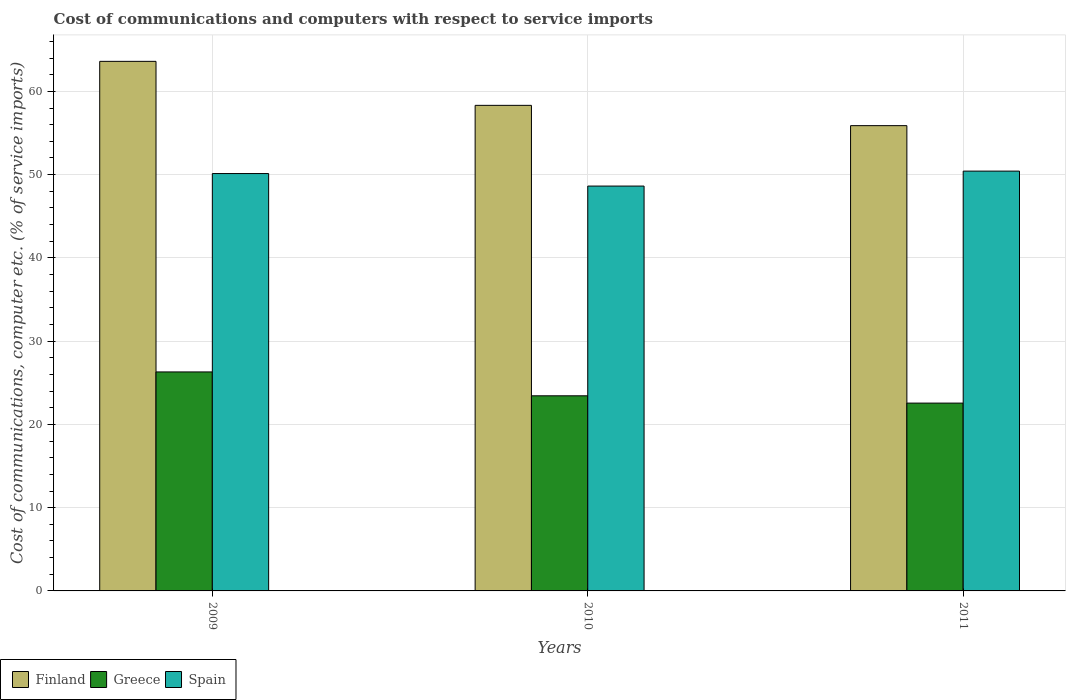How many different coloured bars are there?
Your answer should be very brief. 3. How many groups of bars are there?
Give a very brief answer. 3. Are the number of bars per tick equal to the number of legend labels?
Provide a short and direct response. Yes. Are the number of bars on each tick of the X-axis equal?
Keep it short and to the point. Yes. In how many cases, is the number of bars for a given year not equal to the number of legend labels?
Offer a terse response. 0. What is the cost of communications and computers in Spain in 2011?
Provide a succinct answer. 50.42. Across all years, what is the maximum cost of communications and computers in Spain?
Keep it short and to the point. 50.42. Across all years, what is the minimum cost of communications and computers in Greece?
Your answer should be compact. 22.56. In which year was the cost of communications and computers in Finland minimum?
Your answer should be compact. 2011. What is the total cost of communications and computers in Spain in the graph?
Your answer should be compact. 149.18. What is the difference between the cost of communications and computers in Spain in 2010 and that in 2011?
Ensure brevity in your answer.  -1.79. What is the difference between the cost of communications and computers in Finland in 2010 and the cost of communications and computers in Greece in 2009?
Ensure brevity in your answer.  32.02. What is the average cost of communications and computers in Greece per year?
Provide a succinct answer. 24.1. In the year 2011, what is the difference between the cost of communications and computers in Spain and cost of communications and computers in Finland?
Make the answer very short. -5.46. In how many years, is the cost of communications and computers in Spain greater than 58 %?
Give a very brief answer. 0. What is the ratio of the cost of communications and computers in Finland in 2009 to that in 2011?
Ensure brevity in your answer.  1.14. Is the cost of communications and computers in Spain in 2009 less than that in 2010?
Provide a succinct answer. No. What is the difference between the highest and the second highest cost of communications and computers in Spain?
Keep it short and to the point. 0.29. What is the difference between the highest and the lowest cost of communications and computers in Finland?
Ensure brevity in your answer.  7.72. In how many years, is the cost of communications and computers in Spain greater than the average cost of communications and computers in Spain taken over all years?
Your answer should be compact. 2. Is the sum of the cost of communications and computers in Finland in 2009 and 2010 greater than the maximum cost of communications and computers in Greece across all years?
Make the answer very short. Yes. What does the 3rd bar from the left in 2011 represents?
Offer a terse response. Spain. How many bars are there?
Ensure brevity in your answer.  9. What is the difference between two consecutive major ticks on the Y-axis?
Offer a very short reply. 10. Does the graph contain any zero values?
Your answer should be compact. No. Does the graph contain grids?
Your response must be concise. Yes. Where does the legend appear in the graph?
Give a very brief answer. Bottom left. How many legend labels are there?
Ensure brevity in your answer.  3. How are the legend labels stacked?
Ensure brevity in your answer.  Horizontal. What is the title of the graph?
Offer a terse response. Cost of communications and computers with respect to service imports. What is the label or title of the Y-axis?
Offer a very short reply. Cost of communications, computer etc. (% of service imports). What is the Cost of communications, computer etc. (% of service imports) of Finland in 2009?
Keep it short and to the point. 63.61. What is the Cost of communications, computer etc. (% of service imports) in Greece in 2009?
Make the answer very short. 26.3. What is the Cost of communications, computer etc. (% of service imports) of Spain in 2009?
Your answer should be very brief. 50.13. What is the Cost of communications, computer etc. (% of service imports) in Finland in 2010?
Keep it short and to the point. 58.32. What is the Cost of communications, computer etc. (% of service imports) in Greece in 2010?
Give a very brief answer. 23.44. What is the Cost of communications, computer etc. (% of service imports) of Spain in 2010?
Offer a terse response. 48.63. What is the Cost of communications, computer etc. (% of service imports) in Finland in 2011?
Make the answer very short. 55.88. What is the Cost of communications, computer etc. (% of service imports) of Greece in 2011?
Provide a short and direct response. 22.56. What is the Cost of communications, computer etc. (% of service imports) in Spain in 2011?
Your answer should be very brief. 50.42. Across all years, what is the maximum Cost of communications, computer etc. (% of service imports) in Finland?
Provide a succinct answer. 63.61. Across all years, what is the maximum Cost of communications, computer etc. (% of service imports) in Greece?
Offer a terse response. 26.3. Across all years, what is the maximum Cost of communications, computer etc. (% of service imports) in Spain?
Keep it short and to the point. 50.42. Across all years, what is the minimum Cost of communications, computer etc. (% of service imports) of Finland?
Your answer should be compact. 55.88. Across all years, what is the minimum Cost of communications, computer etc. (% of service imports) of Greece?
Make the answer very short. 22.56. Across all years, what is the minimum Cost of communications, computer etc. (% of service imports) of Spain?
Your answer should be compact. 48.63. What is the total Cost of communications, computer etc. (% of service imports) of Finland in the graph?
Offer a terse response. 177.81. What is the total Cost of communications, computer etc. (% of service imports) of Greece in the graph?
Your answer should be very brief. 72.3. What is the total Cost of communications, computer etc. (% of service imports) in Spain in the graph?
Your response must be concise. 149.18. What is the difference between the Cost of communications, computer etc. (% of service imports) of Finland in 2009 and that in 2010?
Make the answer very short. 5.28. What is the difference between the Cost of communications, computer etc. (% of service imports) of Greece in 2009 and that in 2010?
Keep it short and to the point. 2.87. What is the difference between the Cost of communications, computer etc. (% of service imports) in Spain in 2009 and that in 2010?
Give a very brief answer. 1.5. What is the difference between the Cost of communications, computer etc. (% of service imports) of Finland in 2009 and that in 2011?
Your answer should be very brief. 7.72. What is the difference between the Cost of communications, computer etc. (% of service imports) in Greece in 2009 and that in 2011?
Your answer should be very brief. 3.74. What is the difference between the Cost of communications, computer etc. (% of service imports) of Spain in 2009 and that in 2011?
Your answer should be very brief. -0.29. What is the difference between the Cost of communications, computer etc. (% of service imports) of Finland in 2010 and that in 2011?
Keep it short and to the point. 2.44. What is the difference between the Cost of communications, computer etc. (% of service imports) of Greece in 2010 and that in 2011?
Ensure brevity in your answer.  0.88. What is the difference between the Cost of communications, computer etc. (% of service imports) of Spain in 2010 and that in 2011?
Give a very brief answer. -1.79. What is the difference between the Cost of communications, computer etc. (% of service imports) of Finland in 2009 and the Cost of communications, computer etc. (% of service imports) of Greece in 2010?
Provide a short and direct response. 40.17. What is the difference between the Cost of communications, computer etc. (% of service imports) of Finland in 2009 and the Cost of communications, computer etc. (% of service imports) of Spain in 2010?
Provide a short and direct response. 14.98. What is the difference between the Cost of communications, computer etc. (% of service imports) of Greece in 2009 and the Cost of communications, computer etc. (% of service imports) of Spain in 2010?
Keep it short and to the point. -22.32. What is the difference between the Cost of communications, computer etc. (% of service imports) in Finland in 2009 and the Cost of communications, computer etc. (% of service imports) in Greece in 2011?
Your response must be concise. 41.05. What is the difference between the Cost of communications, computer etc. (% of service imports) of Finland in 2009 and the Cost of communications, computer etc. (% of service imports) of Spain in 2011?
Provide a succinct answer. 13.18. What is the difference between the Cost of communications, computer etc. (% of service imports) of Greece in 2009 and the Cost of communications, computer etc. (% of service imports) of Spain in 2011?
Your response must be concise. -24.12. What is the difference between the Cost of communications, computer etc. (% of service imports) of Finland in 2010 and the Cost of communications, computer etc. (% of service imports) of Greece in 2011?
Make the answer very short. 35.76. What is the difference between the Cost of communications, computer etc. (% of service imports) in Finland in 2010 and the Cost of communications, computer etc. (% of service imports) in Spain in 2011?
Offer a very short reply. 7.9. What is the difference between the Cost of communications, computer etc. (% of service imports) in Greece in 2010 and the Cost of communications, computer etc. (% of service imports) in Spain in 2011?
Ensure brevity in your answer.  -26.99. What is the average Cost of communications, computer etc. (% of service imports) of Finland per year?
Your answer should be compact. 59.27. What is the average Cost of communications, computer etc. (% of service imports) in Greece per year?
Make the answer very short. 24.1. What is the average Cost of communications, computer etc. (% of service imports) in Spain per year?
Your answer should be very brief. 49.73. In the year 2009, what is the difference between the Cost of communications, computer etc. (% of service imports) in Finland and Cost of communications, computer etc. (% of service imports) in Greece?
Offer a terse response. 37.3. In the year 2009, what is the difference between the Cost of communications, computer etc. (% of service imports) of Finland and Cost of communications, computer etc. (% of service imports) of Spain?
Give a very brief answer. 13.48. In the year 2009, what is the difference between the Cost of communications, computer etc. (% of service imports) of Greece and Cost of communications, computer etc. (% of service imports) of Spain?
Your answer should be very brief. -23.83. In the year 2010, what is the difference between the Cost of communications, computer etc. (% of service imports) in Finland and Cost of communications, computer etc. (% of service imports) in Greece?
Offer a terse response. 34.89. In the year 2010, what is the difference between the Cost of communications, computer etc. (% of service imports) in Finland and Cost of communications, computer etc. (% of service imports) in Spain?
Offer a very short reply. 9.7. In the year 2010, what is the difference between the Cost of communications, computer etc. (% of service imports) in Greece and Cost of communications, computer etc. (% of service imports) in Spain?
Your response must be concise. -25.19. In the year 2011, what is the difference between the Cost of communications, computer etc. (% of service imports) in Finland and Cost of communications, computer etc. (% of service imports) in Greece?
Your response must be concise. 33.33. In the year 2011, what is the difference between the Cost of communications, computer etc. (% of service imports) in Finland and Cost of communications, computer etc. (% of service imports) in Spain?
Your answer should be very brief. 5.46. In the year 2011, what is the difference between the Cost of communications, computer etc. (% of service imports) in Greece and Cost of communications, computer etc. (% of service imports) in Spain?
Provide a succinct answer. -27.86. What is the ratio of the Cost of communications, computer etc. (% of service imports) of Finland in 2009 to that in 2010?
Offer a very short reply. 1.09. What is the ratio of the Cost of communications, computer etc. (% of service imports) of Greece in 2009 to that in 2010?
Keep it short and to the point. 1.12. What is the ratio of the Cost of communications, computer etc. (% of service imports) in Spain in 2009 to that in 2010?
Make the answer very short. 1.03. What is the ratio of the Cost of communications, computer etc. (% of service imports) of Finland in 2009 to that in 2011?
Keep it short and to the point. 1.14. What is the ratio of the Cost of communications, computer etc. (% of service imports) in Greece in 2009 to that in 2011?
Offer a terse response. 1.17. What is the ratio of the Cost of communications, computer etc. (% of service imports) in Spain in 2009 to that in 2011?
Give a very brief answer. 0.99. What is the ratio of the Cost of communications, computer etc. (% of service imports) in Finland in 2010 to that in 2011?
Provide a succinct answer. 1.04. What is the ratio of the Cost of communications, computer etc. (% of service imports) of Greece in 2010 to that in 2011?
Your answer should be compact. 1.04. What is the ratio of the Cost of communications, computer etc. (% of service imports) in Spain in 2010 to that in 2011?
Give a very brief answer. 0.96. What is the difference between the highest and the second highest Cost of communications, computer etc. (% of service imports) of Finland?
Provide a short and direct response. 5.28. What is the difference between the highest and the second highest Cost of communications, computer etc. (% of service imports) in Greece?
Provide a short and direct response. 2.87. What is the difference between the highest and the second highest Cost of communications, computer etc. (% of service imports) in Spain?
Provide a short and direct response. 0.29. What is the difference between the highest and the lowest Cost of communications, computer etc. (% of service imports) in Finland?
Make the answer very short. 7.72. What is the difference between the highest and the lowest Cost of communications, computer etc. (% of service imports) in Greece?
Ensure brevity in your answer.  3.74. What is the difference between the highest and the lowest Cost of communications, computer etc. (% of service imports) in Spain?
Your answer should be very brief. 1.79. 